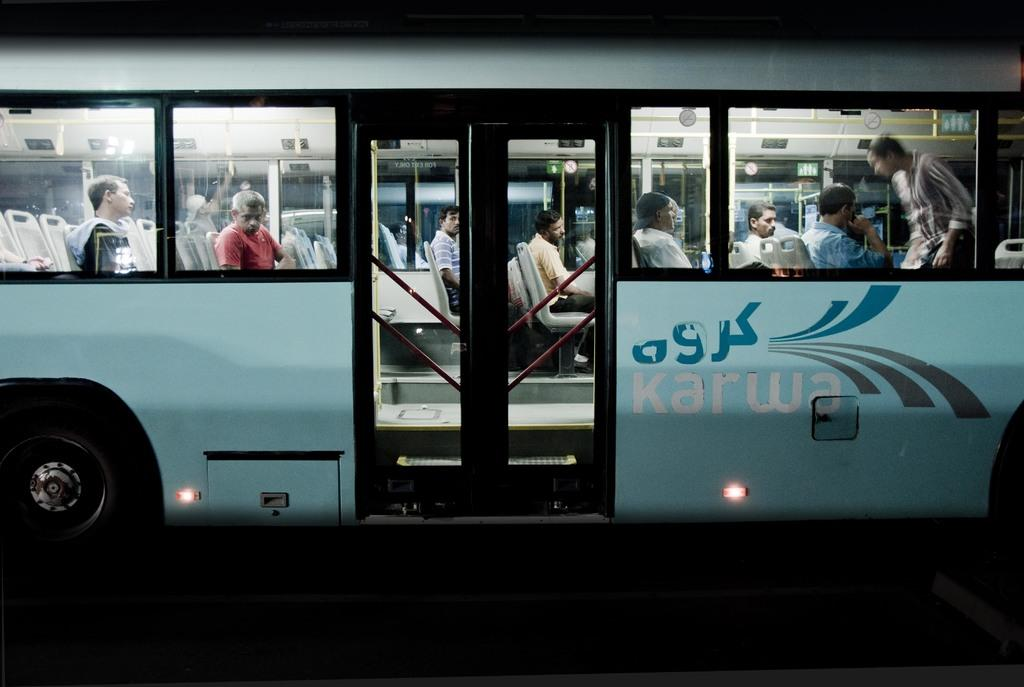What is the main subject of the image? The main subject of the image is a bus. Where is the bus located? The bus is on a road. Are there any passengers in the bus? Yes, there are people sitting in the bus. How many cats can be seen walking on the roof of the bus in the image? There are no cats visible on the roof of the bus in the image. Is there a train present in the image? No, there is no train present in the image; it only features a bus on a road. 